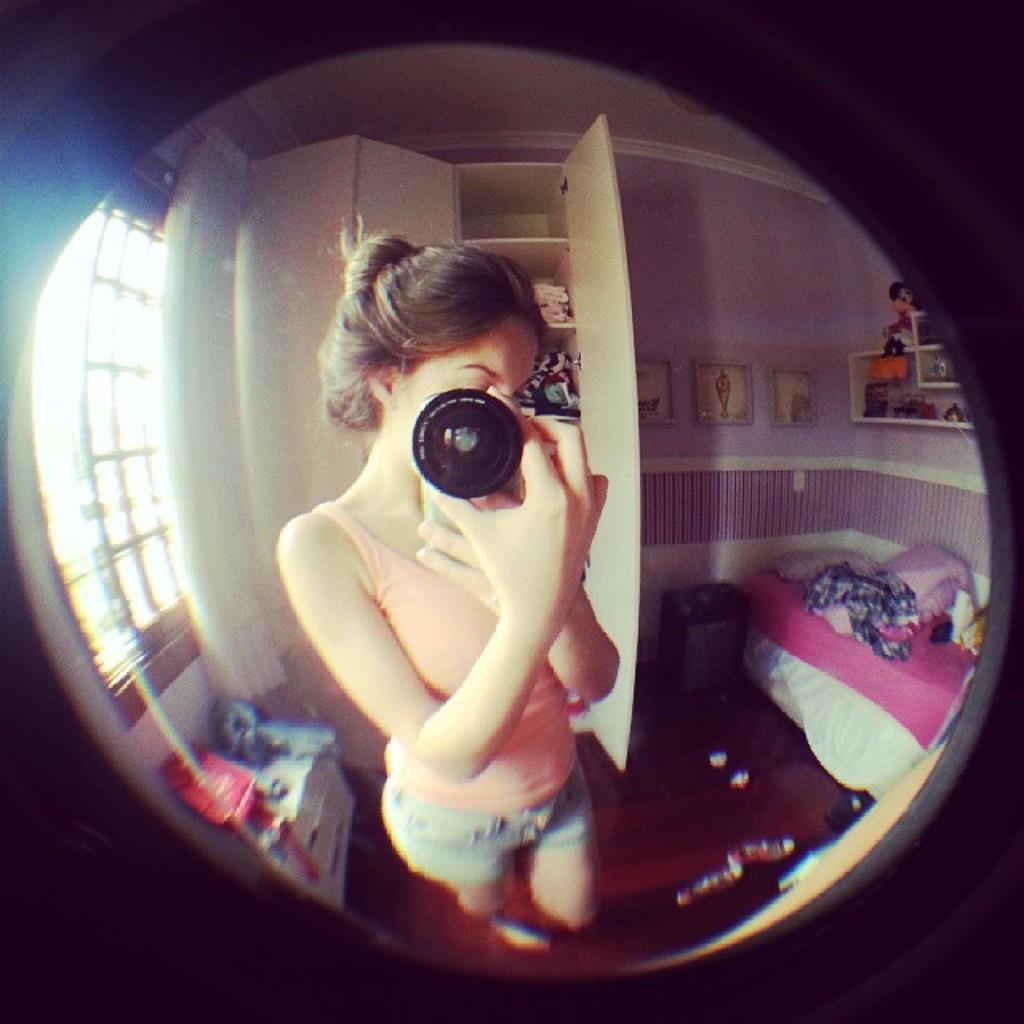Please provide a concise description of this image. This picture shows a woman standing and holding a box in our hands and we see a bed and a door 